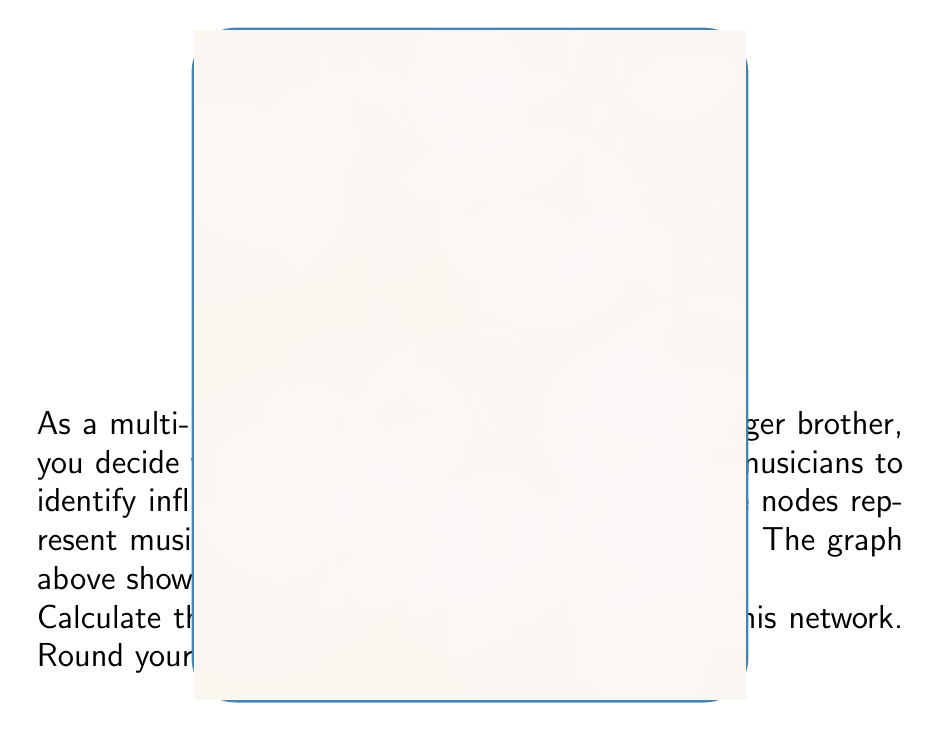Teach me how to tackle this problem. To calculate the betweenness centrality of node B, we need to follow these steps:

1) First, recall that betweenness centrality is calculated as:

   $$C_B(v) = \sum_{s \neq v \neq t} \frac{\sigma_{st}(v)}{\sigma_{st}}$$

   where $\sigma_{st}$ is the total number of shortest paths from node s to node t, and $\sigma_{st}(v)$ is the number of those paths that pass through v.

2) We need to consider all pairs of nodes (excluding B) and count how many shortest paths between them pass through B.

3) Let's go through each pair:

   A-C: shortest path is A-C, doesn't pass through B
   A-D: shortest path is A-D, doesn't pass through B
   A-E: shortest path is A-B-E, passes through B
   A-F: shortest paths are A-B-F and A-C-F, 1 out of 2 passes through B
   C-D: shortest path is C-D, doesn't pass through B
   C-E: shortest path is C-B-E, passes through B
   D-E: shortest path is D-B-E, passes through B
   D-F: shortest paths are D-B-F and D-C-F, 1 out of 2 passes through B
   E-F: shortest path is E-B-F, passes through B

4) Summing up the fractions:

   $$C_B(B) = 1 + \frac{1}{2} + 1 + 1 + \frac{1}{2} + 1 = 5$$

5) To normalize this, we divide by the number of possible pairs of nodes excluding B:

   $$\text{Number of pairs} = \frac{(n-1)(n-2)}{2} = \frac{5 \cdot 4}{2} = 10$$

6) Therefore, the normalized betweenness centrality is:

   $$C_B'(B) = \frac{5}{10} = 0.5$$

Rounding to two decimal places gives 0.50.
Answer: 0.50 